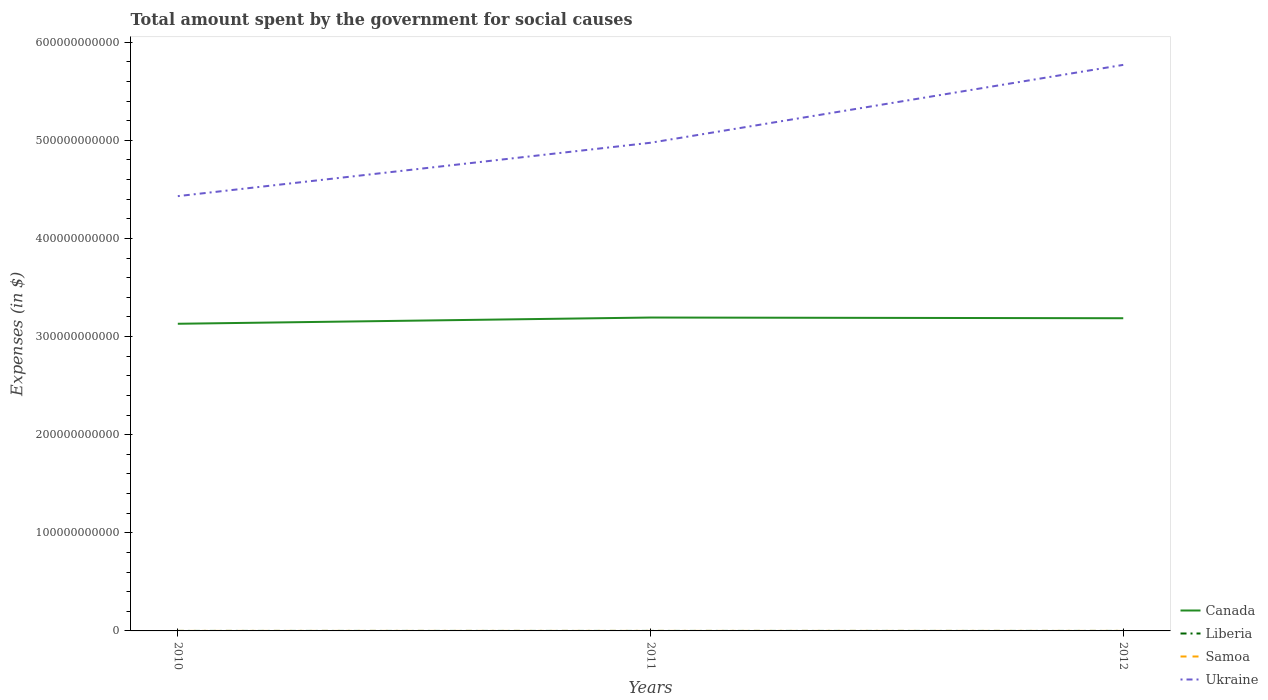How many different coloured lines are there?
Provide a succinct answer. 4. Is the number of lines equal to the number of legend labels?
Your answer should be very brief. Yes. Across all years, what is the maximum amount spent for social causes by the government in Ukraine?
Provide a succinct answer. 4.43e+11. In which year was the amount spent for social causes by the government in Samoa maximum?
Ensure brevity in your answer.  2010. What is the total amount spent for social causes by the government in Canada in the graph?
Make the answer very short. -5.62e+09. What is the difference between the highest and the second highest amount spent for social causes by the government in Ukraine?
Offer a terse response. 1.34e+11. What is the difference between the highest and the lowest amount spent for social causes by the government in Samoa?
Keep it short and to the point. 2. How many lines are there?
Provide a short and direct response. 4. What is the difference between two consecutive major ticks on the Y-axis?
Offer a very short reply. 1.00e+11. Does the graph contain any zero values?
Offer a very short reply. No. Does the graph contain grids?
Give a very brief answer. No. How are the legend labels stacked?
Your answer should be very brief. Vertical. What is the title of the graph?
Your response must be concise. Total amount spent by the government for social causes. What is the label or title of the X-axis?
Provide a short and direct response. Years. What is the label or title of the Y-axis?
Your response must be concise. Expenses (in $). What is the Expenses (in $) of Canada in 2010?
Ensure brevity in your answer.  3.13e+11. What is the Expenses (in $) in Liberia in 2010?
Your response must be concise. 3.80e+06. What is the Expenses (in $) in Samoa in 2010?
Provide a succinct answer. 4.32e+05. What is the Expenses (in $) in Ukraine in 2010?
Provide a succinct answer. 4.43e+11. What is the Expenses (in $) of Canada in 2011?
Provide a succinct answer. 3.19e+11. What is the Expenses (in $) of Liberia in 2011?
Provide a short and direct response. 4.46e+06. What is the Expenses (in $) of Samoa in 2011?
Ensure brevity in your answer.  4.53e+05. What is the Expenses (in $) of Ukraine in 2011?
Provide a short and direct response. 4.98e+11. What is the Expenses (in $) in Canada in 2012?
Your answer should be very brief. 3.19e+11. What is the Expenses (in $) in Liberia in 2012?
Your answer should be compact. 5.86e+06. What is the Expenses (in $) in Samoa in 2012?
Your answer should be very brief. 4.53e+05. What is the Expenses (in $) in Ukraine in 2012?
Your response must be concise. 5.77e+11. Across all years, what is the maximum Expenses (in $) in Canada?
Offer a very short reply. 3.19e+11. Across all years, what is the maximum Expenses (in $) in Liberia?
Offer a very short reply. 5.86e+06. Across all years, what is the maximum Expenses (in $) of Samoa?
Provide a short and direct response. 4.53e+05. Across all years, what is the maximum Expenses (in $) of Ukraine?
Your answer should be compact. 5.77e+11. Across all years, what is the minimum Expenses (in $) in Canada?
Your answer should be very brief. 3.13e+11. Across all years, what is the minimum Expenses (in $) of Liberia?
Your answer should be very brief. 3.80e+06. Across all years, what is the minimum Expenses (in $) in Samoa?
Offer a very short reply. 4.32e+05. Across all years, what is the minimum Expenses (in $) in Ukraine?
Ensure brevity in your answer.  4.43e+11. What is the total Expenses (in $) in Canada in the graph?
Keep it short and to the point. 9.51e+11. What is the total Expenses (in $) in Liberia in the graph?
Offer a very short reply. 1.41e+07. What is the total Expenses (in $) in Samoa in the graph?
Provide a short and direct response. 1.34e+06. What is the total Expenses (in $) of Ukraine in the graph?
Your response must be concise. 1.52e+12. What is the difference between the Expenses (in $) in Canada in 2010 and that in 2011?
Offer a very short reply. -6.35e+09. What is the difference between the Expenses (in $) of Liberia in 2010 and that in 2011?
Provide a succinct answer. -6.67e+05. What is the difference between the Expenses (in $) of Samoa in 2010 and that in 2011?
Your answer should be very brief. -2.12e+04. What is the difference between the Expenses (in $) of Ukraine in 2010 and that in 2011?
Offer a terse response. -5.44e+1. What is the difference between the Expenses (in $) in Canada in 2010 and that in 2012?
Your answer should be very brief. -5.62e+09. What is the difference between the Expenses (in $) of Liberia in 2010 and that in 2012?
Provide a short and direct response. -2.06e+06. What is the difference between the Expenses (in $) of Samoa in 2010 and that in 2012?
Your answer should be compact. -2.12e+04. What is the difference between the Expenses (in $) of Ukraine in 2010 and that in 2012?
Offer a terse response. -1.34e+11. What is the difference between the Expenses (in $) of Canada in 2011 and that in 2012?
Keep it short and to the point. 7.23e+08. What is the difference between the Expenses (in $) in Liberia in 2011 and that in 2012?
Your response must be concise. -1.40e+06. What is the difference between the Expenses (in $) of Samoa in 2011 and that in 2012?
Your response must be concise. -5.38. What is the difference between the Expenses (in $) in Ukraine in 2011 and that in 2012?
Provide a succinct answer. -7.94e+1. What is the difference between the Expenses (in $) of Canada in 2010 and the Expenses (in $) of Liberia in 2011?
Provide a succinct answer. 3.13e+11. What is the difference between the Expenses (in $) of Canada in 2010 and the Expenses (in $) of Samoa in 2011?
Keep it short and to the point. 3.13e+11. What is the difference between the Expenses (in $) of Canada in 2010 and the Expenses (in $) of Ukraine in 2011?
Offer a terse response. -1.84e+11. What is the difference between the Expenses (in $) of Liberia in 2010 and the Expenses (in $) of Samoa in 2011?
Ensure brevity in your answer.  3.34e+06. What is the difference between the Expenses (in $) of Liberia in 2010 and the Expenses (in $) of Ukraine in 2011?
Ensure brevity in your answer.  -4.98e+11. What is the difference between the Expenses (in $) of Samoa in 2010 and the Expenses (in $) of Ukraine in 2011?
Make the answer very short. -4.98e+11. What is the difference between the Expenses (in $) in Canada in 2010 and the Expenses (in $) in Liberia in 2012?
Your answer should be very brief. 3.13e+11. What is the difference between the Expenses (in $) in Canada in 2010 and the Expenses (in $) in Samoa in 2012?
Your answer should be compact. 3.13e+11. What is the difference between the Expenses (in $) in Canada in 2010 and the Expenses (in $) in Ukraine in 2012?
Keep it short and to the point. -2.64e+11. What is the difference between the Expenses (in $) of Liberia in 2010 and the Expenses (in $) of Samoa in 2012?
Make the answer very short. 3.34e+06. What is the difference between the Expenses (in $) in Liberia in 2010 and the Expenses (in $) in Ukraine in 2012?
Your response must be concise. -5.77e+11. What is the difference between the Expenses (in $) of Samoa in 2010 and the Expenses (in $) of Ukraine in 2012?
Offer a terse response. -5.77e+11. What is the difference between the Expenses (in $) in Canada in 2011 and the Expenses (in $) in Liberia in 2012?
Provide a short and direct response. 3.19e+11. What is the difference between the Expenses (in $) in Canada in 2011 and the Expenses (in $) in Samoa in 2012?
Your response must be concise. 3.19e+11. What is the difference between the Expenses (in $) in Canada in 2011 and the Expenses (in $) in Ukraine in 2012?
Your answer should be very brief. -2.57e+11. What is the difference between the Expenses (in $) of Liberia in 2011 and the Expenses (in $) of Samoa in 2012?
Ensure brevity in your answer.  4.01e+06. What is the difference between the Expenses (in $) in Liberia in 2011 and the Expenses (in $) in Ukraine in 2012?
Offer a very short reply. -5.77e+11. What is the difference between the Expenses (in $) of Samoa in 2011 and the Expenses (in $) of Ukraine in 2012?
Provide a succinct answer. -5.77e+11. What is the average Expenses (in $) in Canada per year?
Your answer should be very brief. 3.17e+11. What is the average Expenses (in $) of Liberia per year?
Offer a terse response. 4.71e+06. What is the average Expenses (in $) in Samoa per year?
Your response must be concise. 4.46e+05. What is the average Expenses (in $) in Ukraine per year?
Provide a succinct answer. 5.06e+11. In the year 2010, what is the difference between the Expenses (in $) of Canada and Expenses (in $) of Liberia?
Your answer should be compact. 3.13e+11. In the year 2010, what is the difference between the Expenses (in $) of Canada and Expenses (in $) of Samoa?
Offer a terse response. 3.13e+11. In the year 2010, what is the difference between the Expenses (in $) in Canada and Expenses (in $) in Ukraine?
Provide a short and direct response. -1.30e+11. In the year 2010, what is the difference between the Expenses (in $) of Liberia and Expenses (in $) of Samoa?
Ensure brevity in your answer.  3.36e+06. In the year 2010, what is the difference between the Expenses (in $) in Liberia and Expenses (in $) in Ukraine?
Provide a succinct answer. -4.43e+11. In the year 2010, what is the difference between the Expenses (in $) in Samoa and Expenses (in $) in Ukraine?
Your answer should be very brief. -4.43e+11. In the year 2011, what is the difference between the Expenses (in $) in Canada and Expenses (in $) in Liberia?
Provide a succinct answer. 3.19e+11. In the year 2011, what is the difference between the Expenses (in $) of Canada and Expenses (in $) of Samoa?
Ensure brevity in your answer.  3.19e+11. In the year 2011, what is the difference between the Expenses (in $) of Canada and Expenses (in $) of Ukraine?
Provide a succinct answer. -1.78e+11. In the year 2011, what is the difference between the Expenses (in $) of Liberia and Expenses (in $) of Samoa?
Provide a succinct answer. 4.01e+06. In the year 2011, what is the difference between the Expenses (in $) of Liberia and Expenses (in $) of Ukraine?
Your answer should be compact. -4.98e+11. In the year 2011, what is the difference between the Expenses (in $) in Samoa and Expenses (in $) in Ukraine?
Ensure brevity in your answer.  -4.98e+11. In the year 2012, what is the difference between the Expenses (in $) in Canada and Expenses (in $) in Liberia?
Your answer should be very brief. 3.19e+11. In the year 2012, what is the difference between the Expenses (in $) in Canada and Expenses (in $) in Samoa?
Your response must be concise. 3.19e+11. In the year 2012, what is the difference between the Expenses (in $) in Canada and Expenses (in $) in Ukraine?
Offer a terse response. -2.58e+11. In the year 2012, what is the difference between the Expenses (in $) of Liberia and Expenses (in $) of Samoa?
Keep it short and to the point. 5.41e+06. In the year 2012, what is the difference between the Expenses (in $) in Liberia and Expenses (in $) in Ukraine?
Your response must be concise. -5.77e+11. In the year 2012, what is the difference between the Expenses (in $) of Samoa and Expenses (in $) of Ukraine?
Offer a terse response. -5.77e+11. What is the ratio of the Expenses (in $) of Canada in 2010 to that in 2011?
Ensure brevity in your answer.  0.98. What is the ratio of the Expenses (in $) in Liberia in 2010 to that in 2011?
Give a very brief answer. 0.85. What is the ratio of the Expenses (in $) of Samoa in 2010 to that in 2011?
Keep it short and to the point. 0.95. What is the ratio of the Expenses (in $) of Ukraine in 2010 to that in 2011?
Offer a terse response. 0.89. What is the ratio of the Expenses (in $) in Canada in 2010 to that in 2012?
Your answer should be very brief. 0.98. What is the ratio of the Expenses (in $) of Liberia in 2010 to that in 2012?
Your answer should be compact. 0.65. What is the ratio of the Expenses (in $) in Samoa in 2010 to that in 2012?
Your answer should be compact. 0.95. What is the ratio of the Expenses (in $) in Ukraine in 2010 to that in 2012?
Give a very brief answer. 0.77. What is the ratio of the Expenses (in $) of Canada in 2011 to that in 2012?
Provide a short and direct response. 1. What is the ratio of the Expenses (in $) in Liberia in 2011 to that in 2012?
Keep it short and to the point. 0.76. What is the ratio of the Expenses (in $) in Ukraine in 2011 to that in 2012?
Give a very brief answer. 0.86. What is the difference between the highest and the second highest Expenses (in $) in Canada?
Make the answer very short. 7.23e+08. What is the difference between the highest and the second highest Expenses (in $) in Liberia?
Give a very brief answer. 1.40e+06. What is the difference between the highest and the second highest Expenses (in $) of Samoa?
Ensure brevity in your answer.  5.38. What is the difference between the highest and the second highest Expenses (in $) in Ukraine?
Ensure brevity in your answer.  7.94e+1. What is the difference between the highest and the lowest Expenses (in $) of Canada?
Make the answer very short. 6.35e+09. What is the difference between the highest and the lowest Expenses (in $) of Liberia?
Offer a terse response. 2.06e+06. What is the difference between the highest and the lowest Expenses (in $) of Samoa?
Make the answer very short. 2.12e+04. What is the difference between the highest and the lowest Expenses (in $) of Ukraine?
Your answer should be very brief. 1.34e+11. 